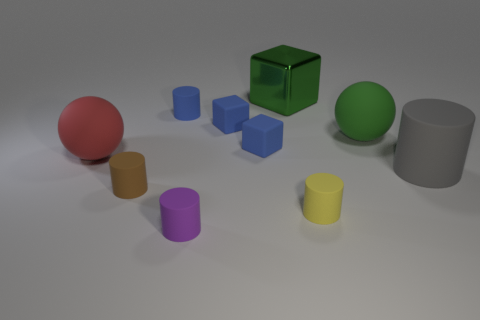Are there more small brown objects than big cyan matte balls?
Make the answer very short. Yes. There is a sphere that is left of the purple cylinder; is there a cylinder that is in front of it?
Offer a very short reply. Yes. What color is the other big matte object that is the same shape as the large green rubber thing?
Offer a terse response. Red. Is there anything else that is the same shape as the shiny object?
Offer a terse response. Yes. What is the color of the large cylinder that is made of the same material as the small yellow object?
Your answer should be compact. Gray. Is there a rubber cylinder behind the tiny rubber cylinder right of the green object that is behind the blue matte cylinder?
Give a very brief answer. Yes. Is the number of brown rubber objects that are behind the green metal thing less than the number of green matte objects that are in front of the purple object?
Offer a terse response. No. What number of tiny brown cylinders are the same material as the large gray cylinder?
Provide a short and direct response. 1. Do the gray rubber cylinder and the purple cylinder left of the green cube have the same size?
Offer a terse response. No. What size is the green thing that is behind the tiny cylinder that is behind the rubber ball that is left of the large green metal object?
Make the answer very short. Large. 